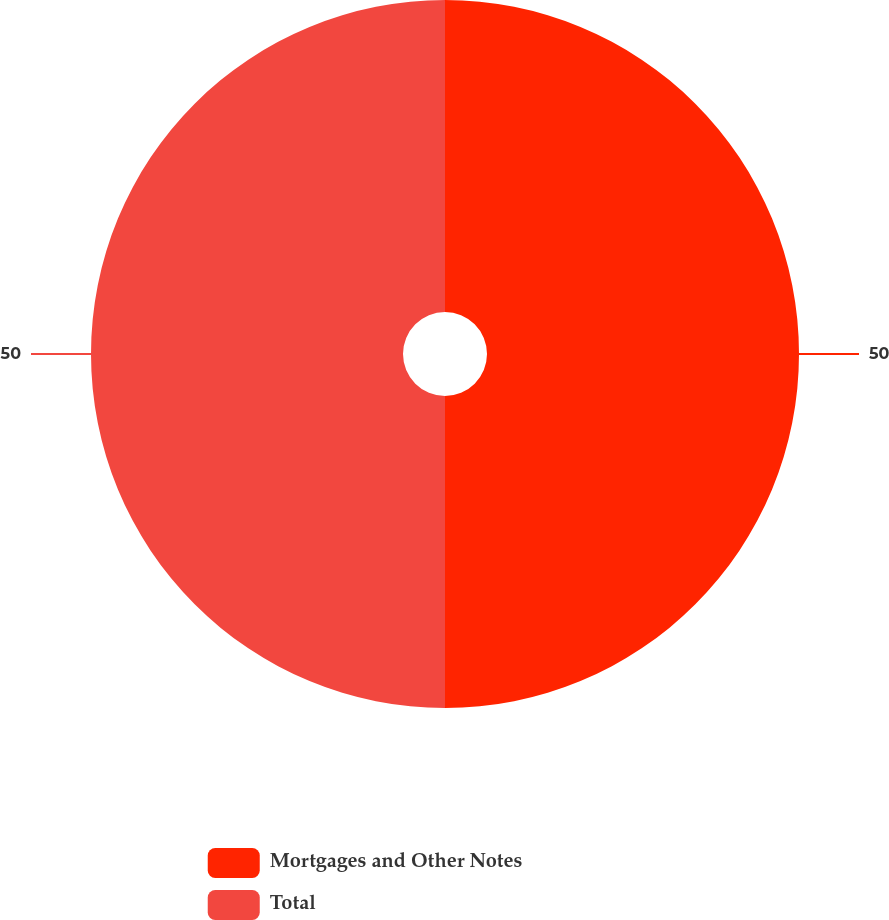Convert chart to OTSL. <chart><loc_0><loc_0><loc_500><loc_500><pie_chart><fcel>Mortgages and Other Notes<fcel>Total<nl><fcel>50.0%<fcel>50.0%<nl></chart> 